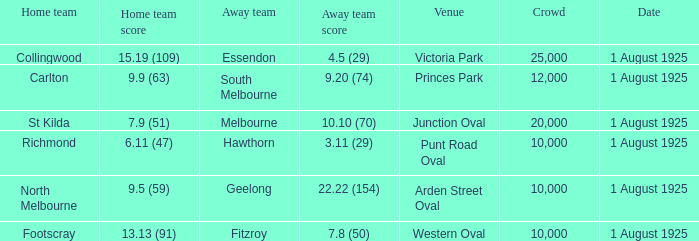During the game at the western oval, what was the score achieved by the away team? 7.8 (50). 